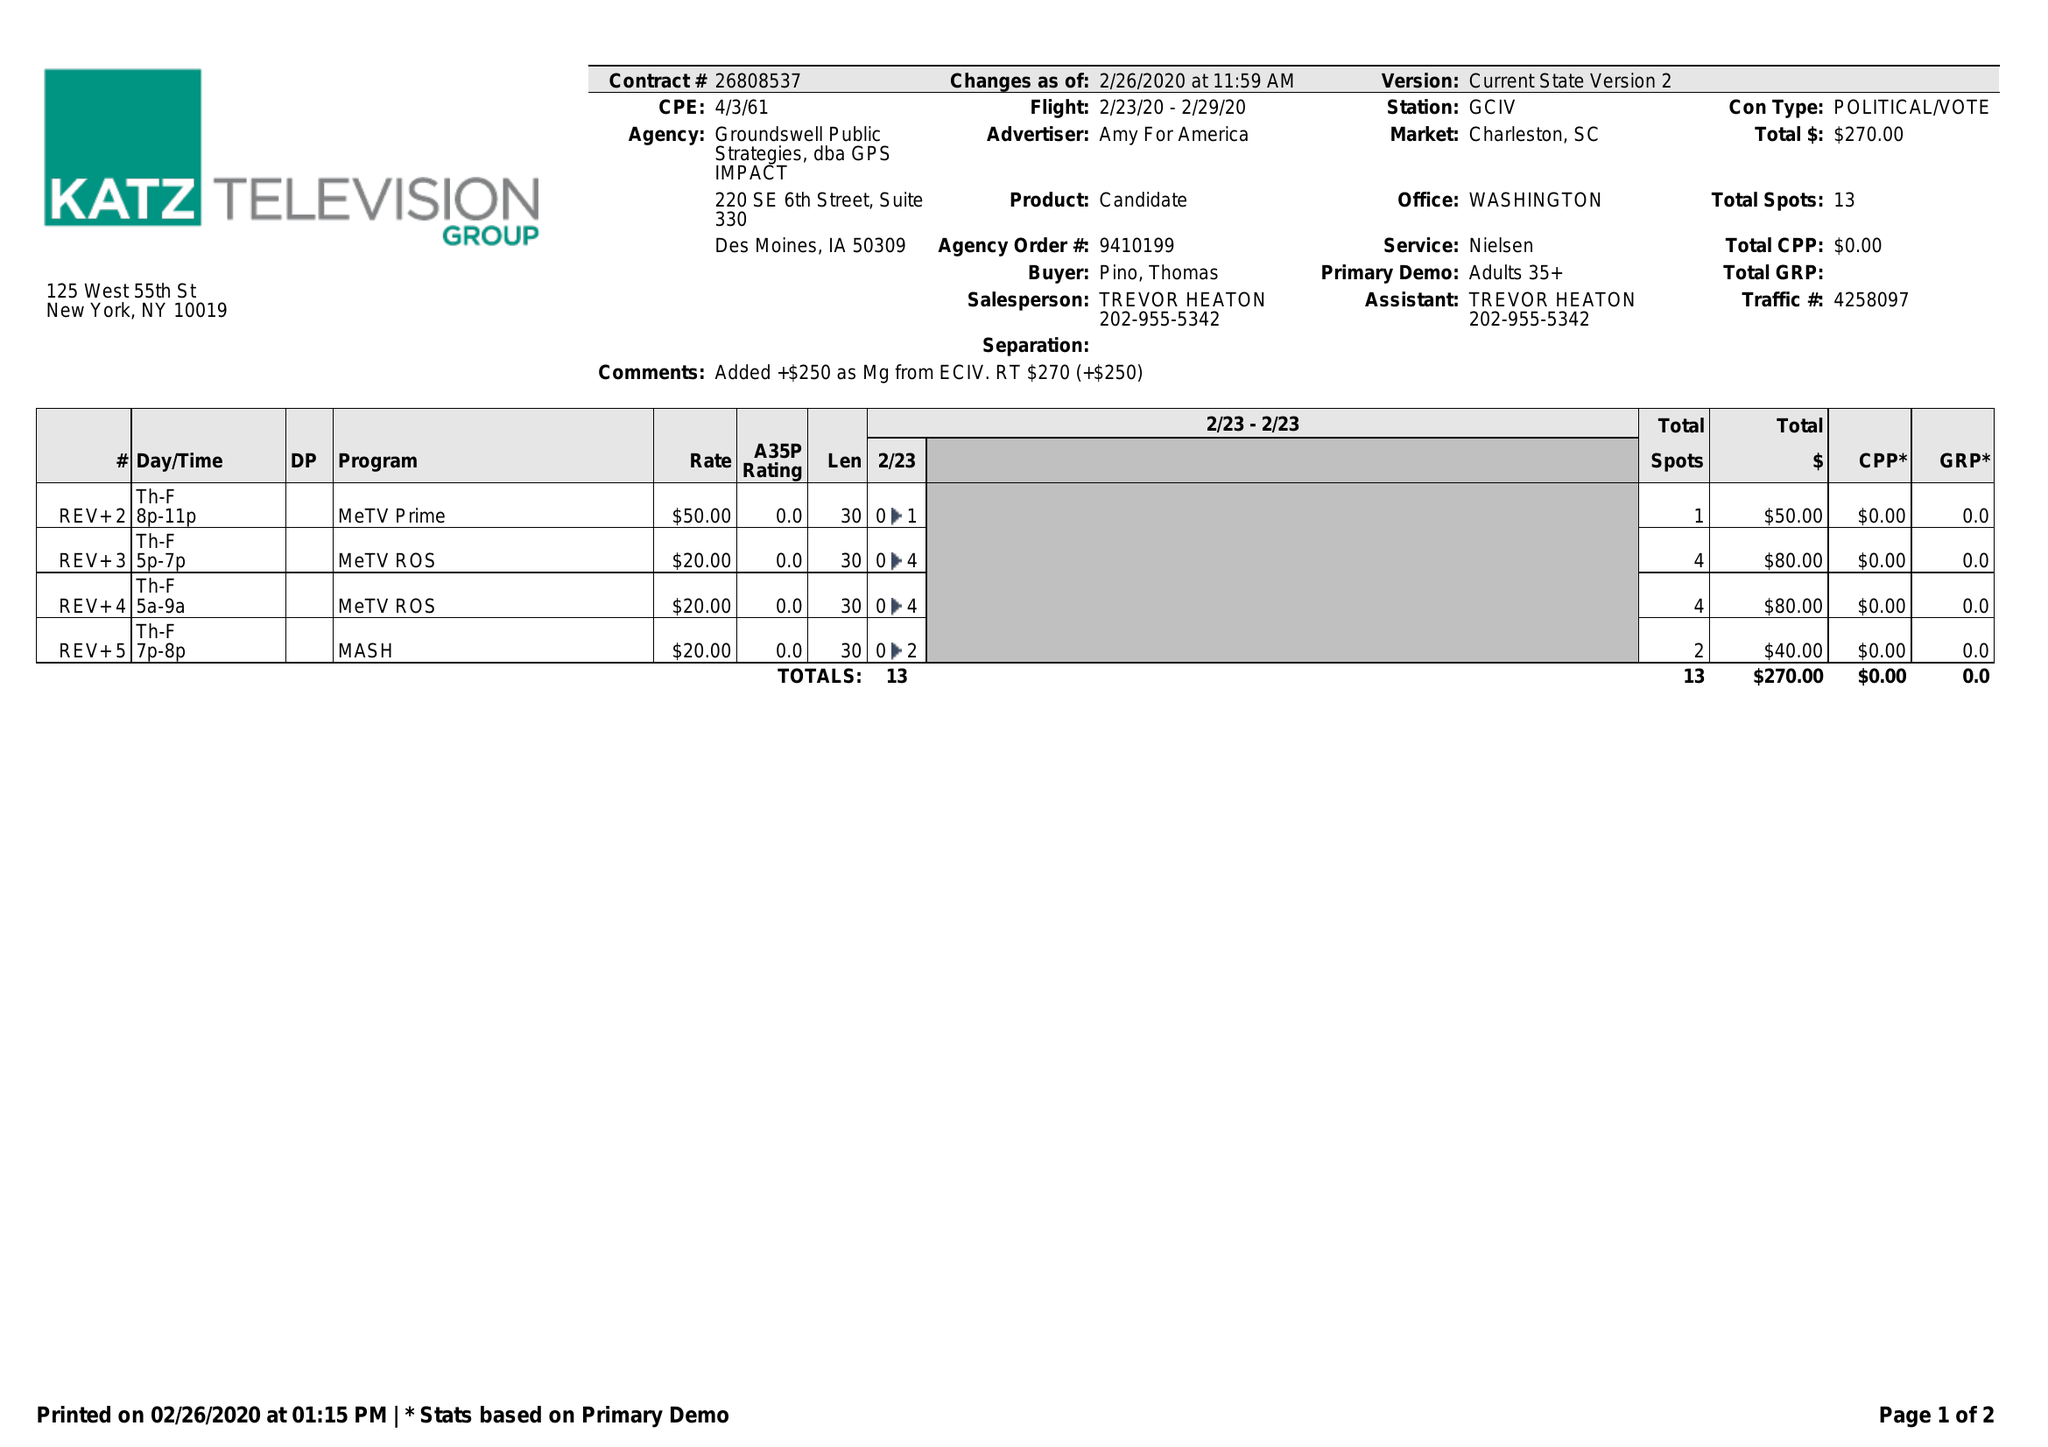What is the value for the flight_to?
Answer the question using a single word or phrase. 02/29/20 